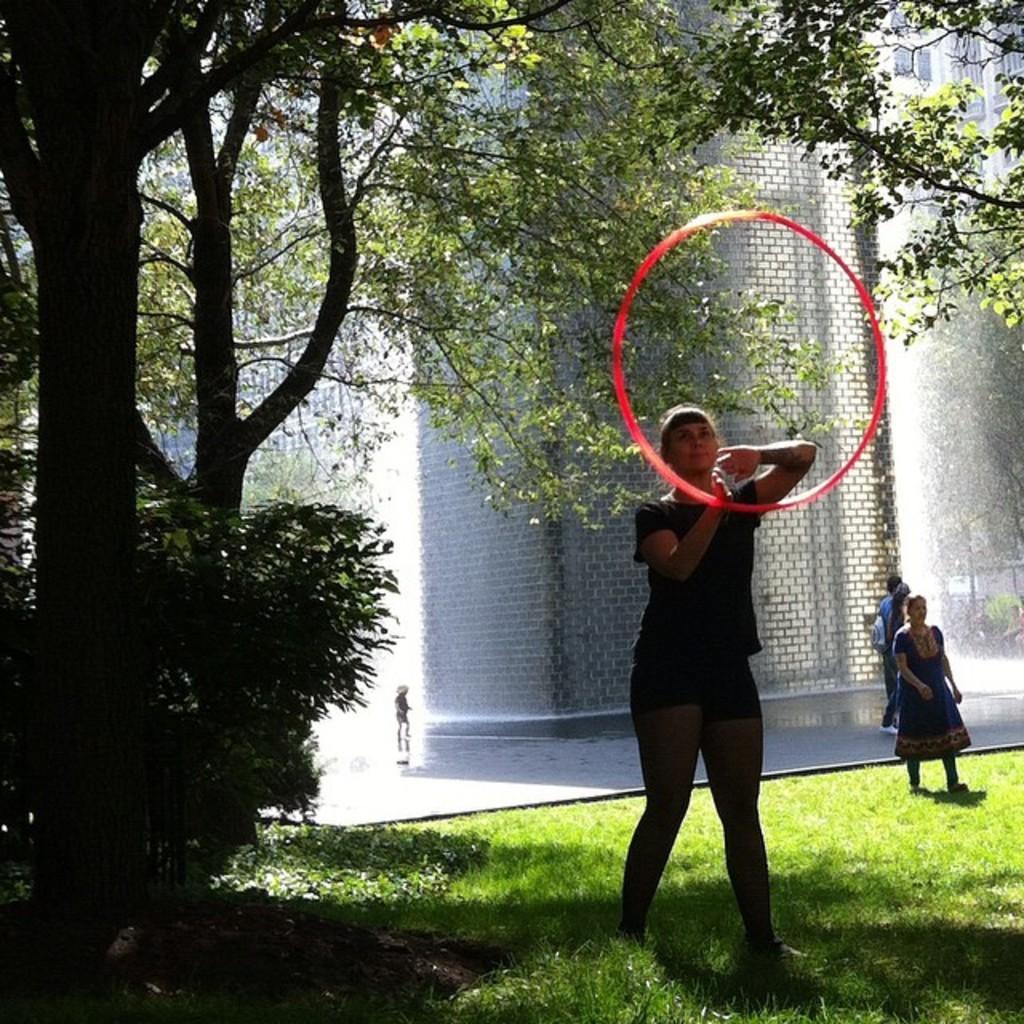Describe this image in one or two sentences. In this image, at the left side there is a woman standing on the grass, she is holding a red color object, at the background there are some people walking, at the left side there is a green color tree. 